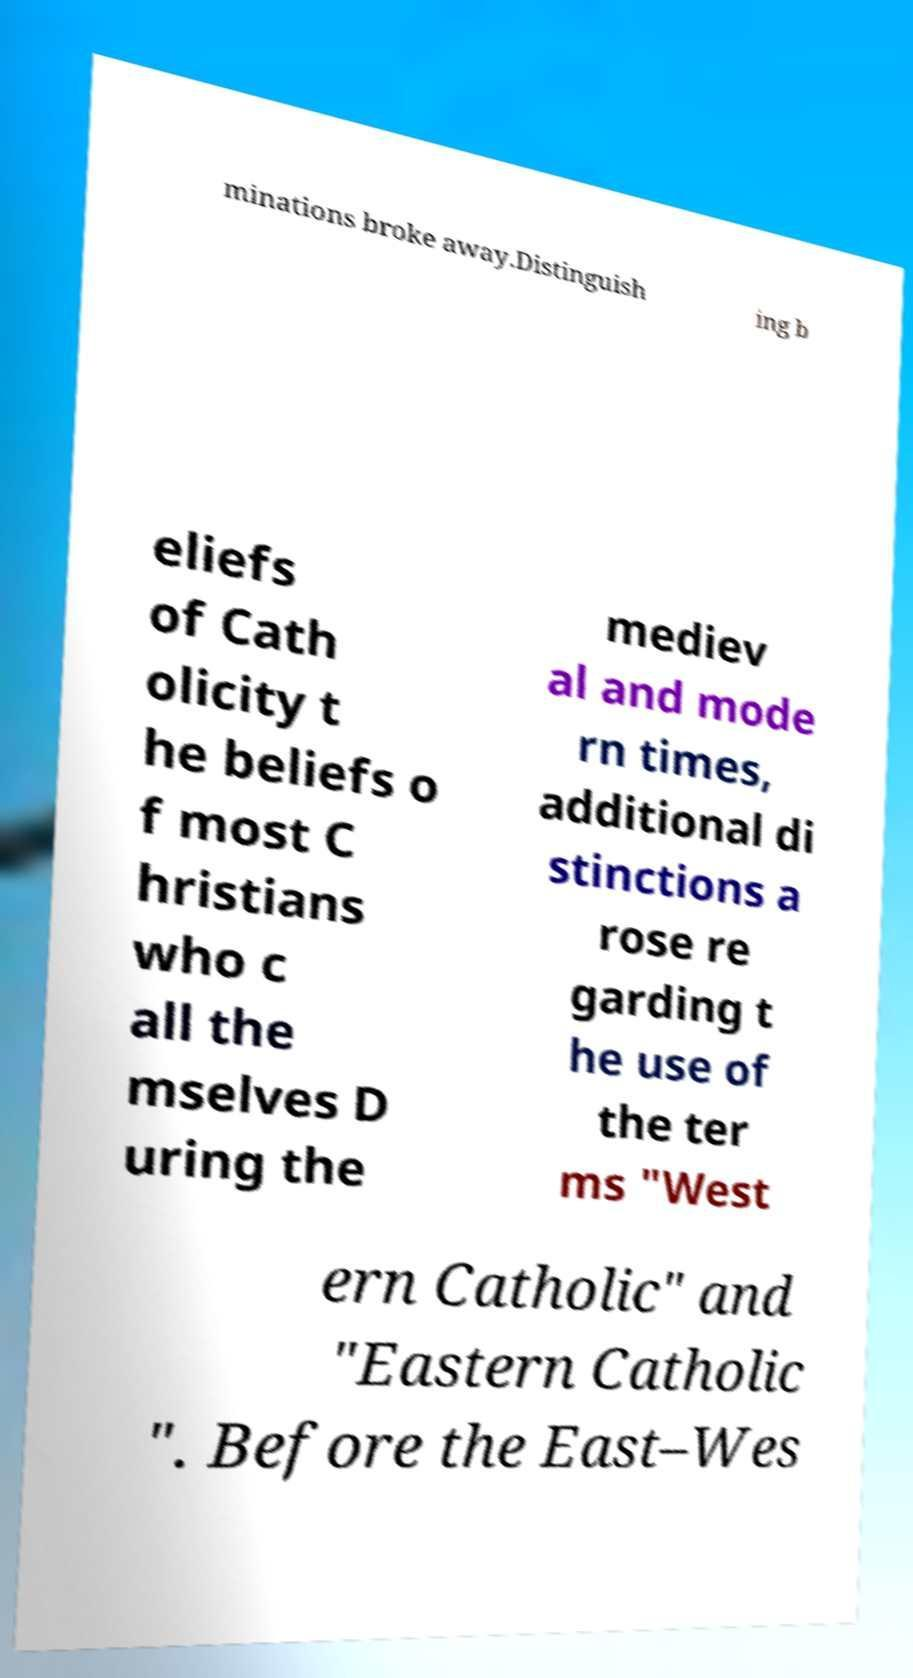I need the written content from this picture converted into text. Can you do that? minations broke away.Distinguish ing b eliefs of Cath olicity t he beliefs o f most C hristians who c all the mselves D uring the mediev al and mode rn times, additional di stinctions a rose re garding t he use of the ter ms "West ern Catholic" and "Eastern Catholic ". Before the East–Wes 